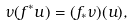Convert formula to latex. <formula><loc_0><loc_0><loc_500><loc_500>\nu ( f ^ { * } u ) = ( f _ { * } \nu ) ( u ) ,</formula> 